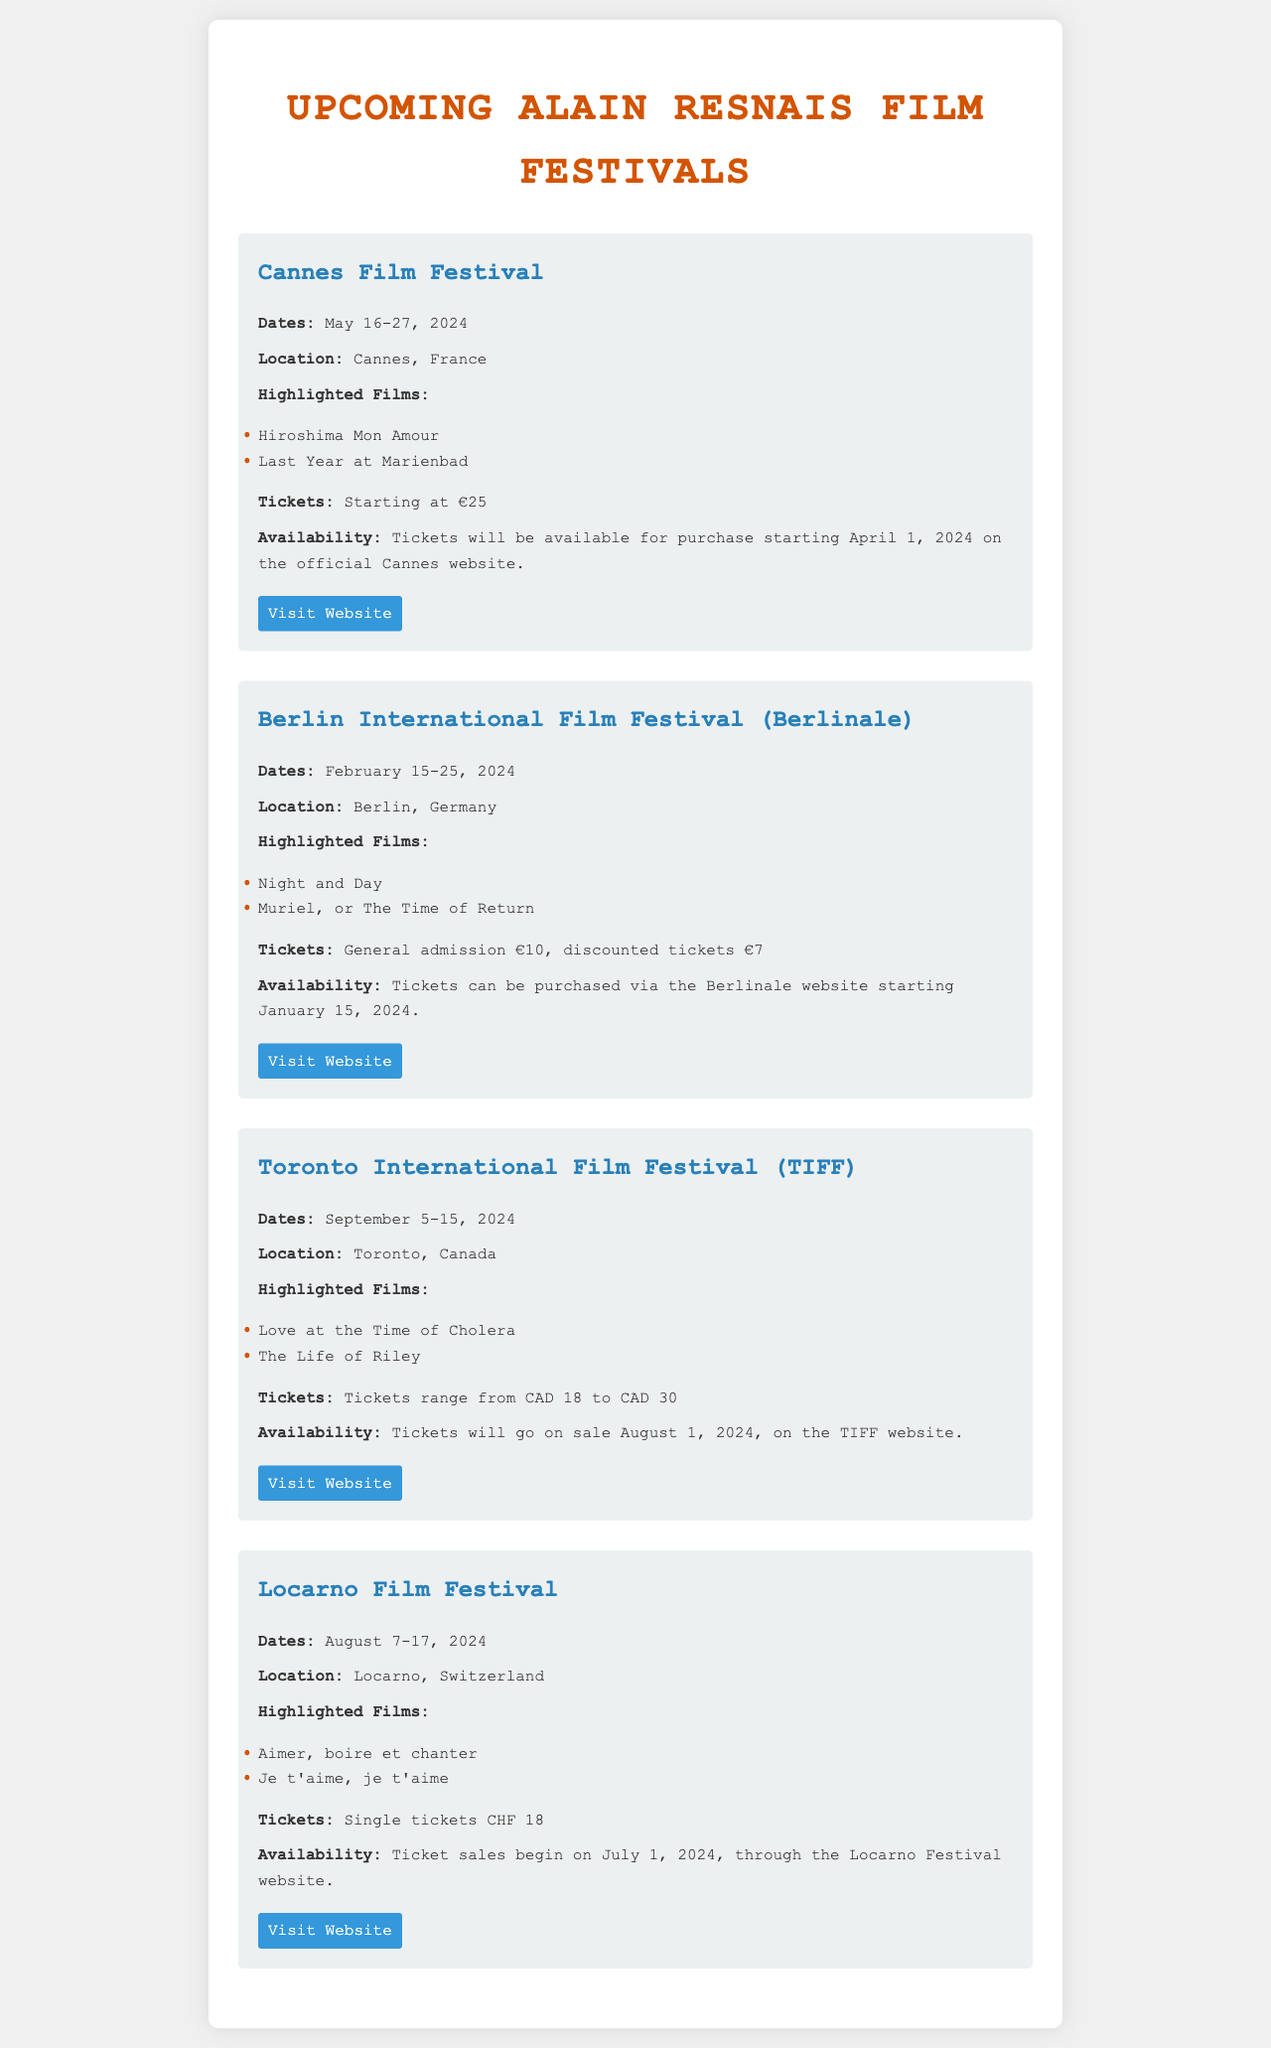What are the dates of the Cannes Film Festival? The document specifies that the Cannes Film Festival will be held from May 16-27, 2024.
Answer: May 16-27, 2024 Where is the Berlinale taking place? According to the document, the Berlin International Film Festival (Berlinale) will take place in Berlin, Germany.
Answer: Berlin, Germany What is the ticket price range for the Toronto International Film Festival? The document states that tickets for TIFF range from CAD 18 to CAD 30.
Answer: CAD 18 to CAD 30 When do ticket sales begin for the Locarno Film Festival? The document mentions that ticket sales for the Locarno Film Festival will begin on July 1, 2024.
Answer: July 1, 2024 Name one highlighted film at the Cannes Film Festival. The document lists "Hiroshima Mon Amour" as one of the highlighted films at the Cannes Film Festival.
Answer: Hiroshima Mon Amour Which film festival features "Muriel, or The Time of Return"? The document indicates that "Muriel, or The Time of Return" is highlighted at the Berlin International Film Festival (Berlinale).
Answer: Berlin International Film Festival What are the dates for the Toronto International Film Festival? The document specifies the dates for the Toronto International Film Festival as September 5-15, 2024.
Answer: September 5-15, 2024 How much do tickets cost at the Berlinale? The document states that general admission costs €10, while discounted tickets are €7.
Answer: €10, €7 What is the location of the Locarno Film Festival? According to the document, the Locarno Film Festival is located in Locarno, Switzerland.
Answer: Locarno, Switzerland 